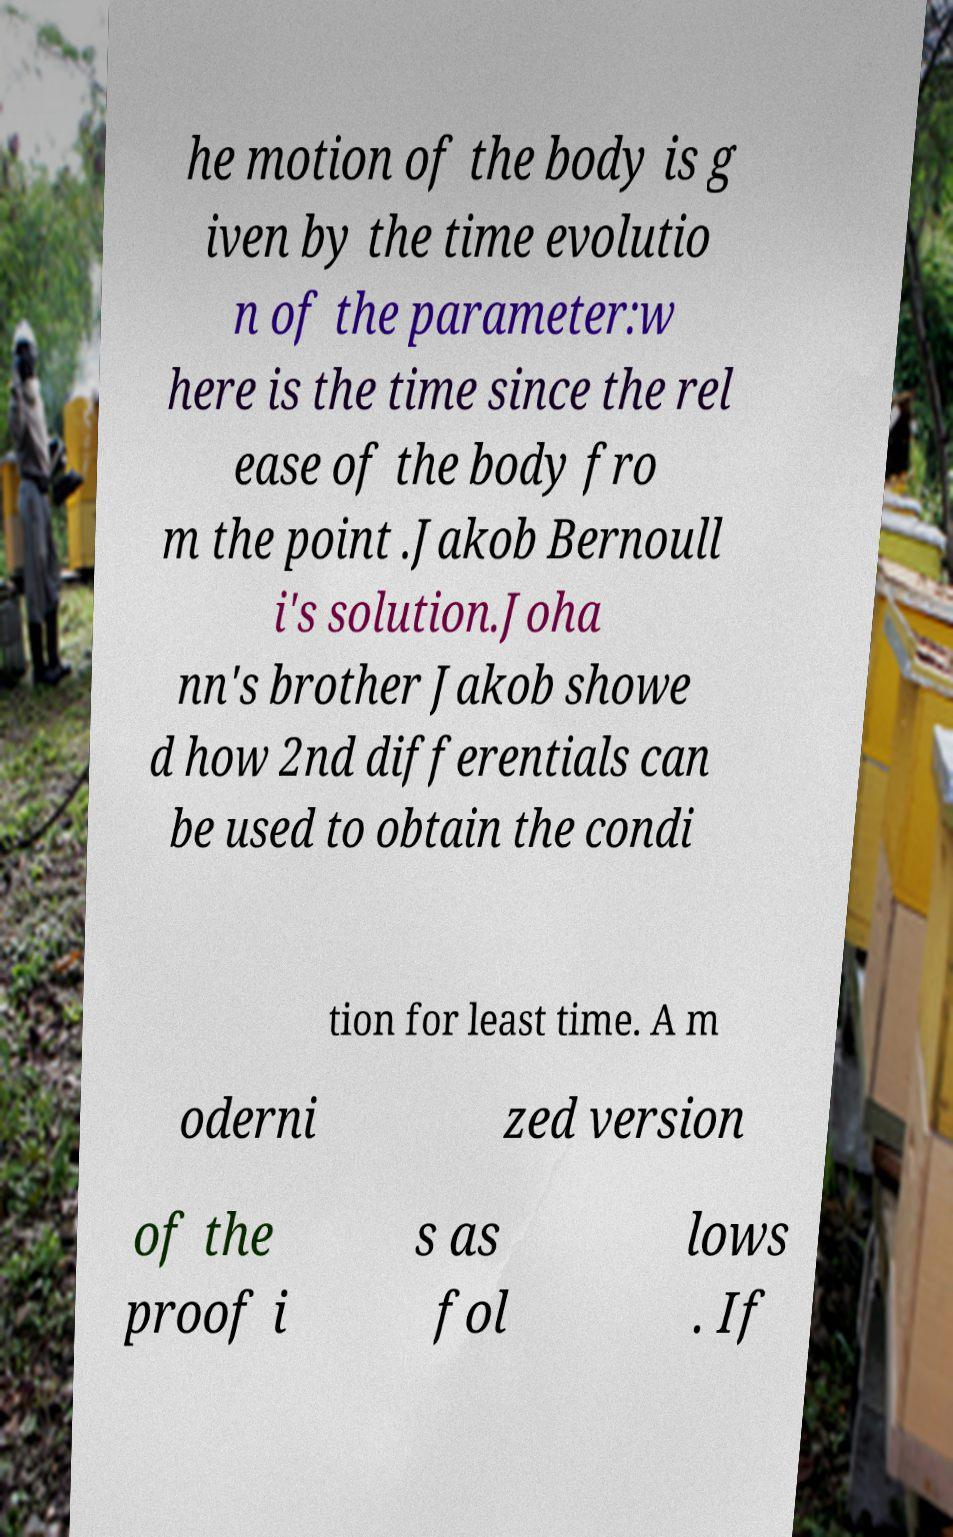Could you extract and type out the text from this image? he motion of the body is g iven by the time evolutio n of the parameter:w here is the time since the rel ease of the body fro m the point .Jakob Bernoull i's solution.Joha nn's brother Jakob showe d how 2nd differentials can be used to obtain the condi tion for least time. A m oderni zed version of the proof i s as fol lows . If 